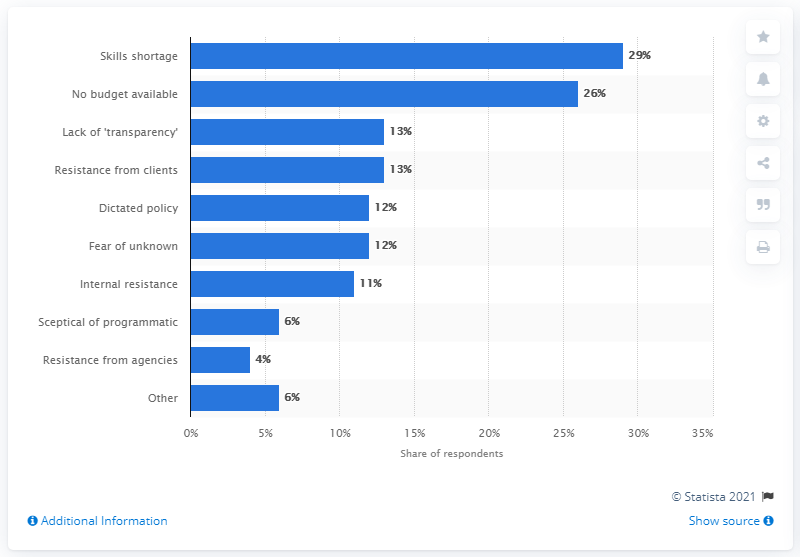Outline some significant characteristics in this image. According to the data, 29% of respondents identified "skills shortage" as the biggest obstacle facing the industry. 